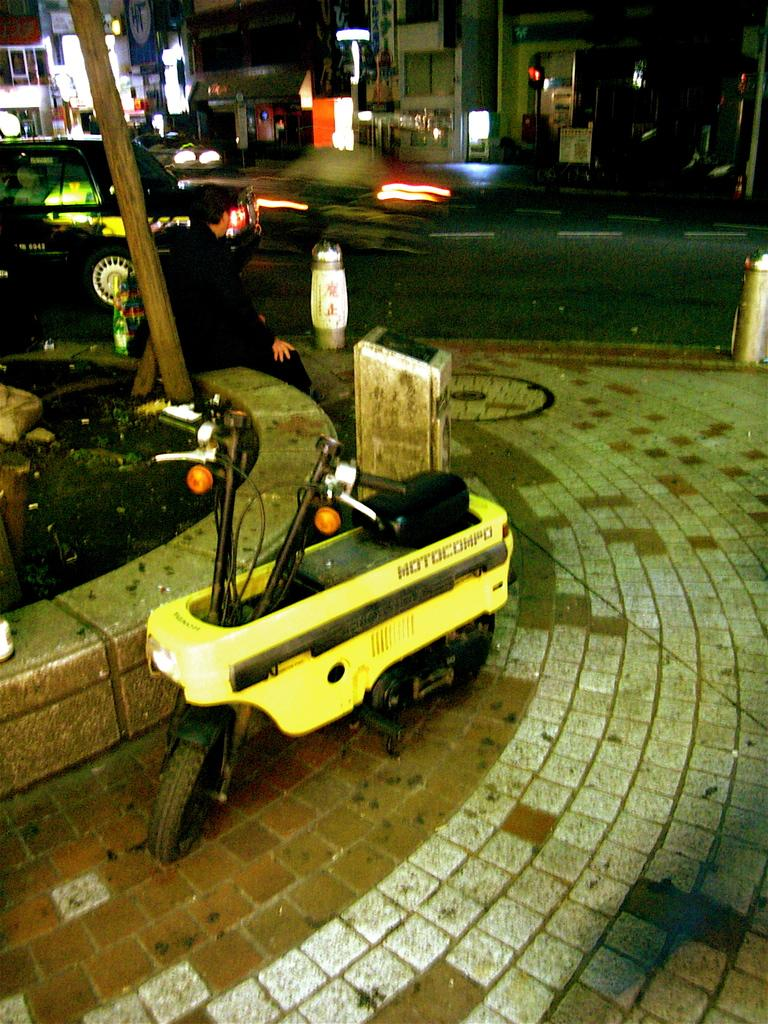What is the main subject in the center of the image? There is a motorcycle in the center of the image. What else can be seen in the background of the image? There is a car on a road and buildings in the background of the image. Can you describe the lighting in the image? Lights are visible in the image. Where is the quiver located in the image? There is no quiver present in the image. How many people are in the crowd in the image? There is no crowd present in the image. 